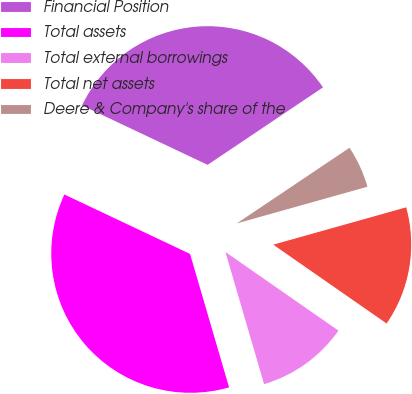Convert chart to OTSL. <chart><loc_0><loc_0><loc_500><loc_500><pie_chart><fcel>Financial Position<fcel>Total assets<fcel>Total external borrowings<fcel>Total net assets<fcel>Deere & Company's share of the<nl><fcel>33.56%<fcel>36.56%<fcel>10.8%<fcel>14.03%<fcel>5.05%<nl></chart> 